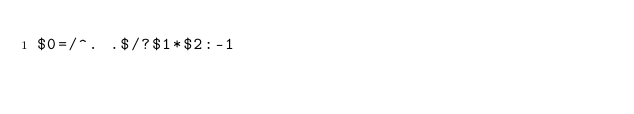Convert code to text. <code><loc_0><loc_0><loc_500><loc_500><_Awk_>$0=/^. .$/?$1*$2:-1</code> 